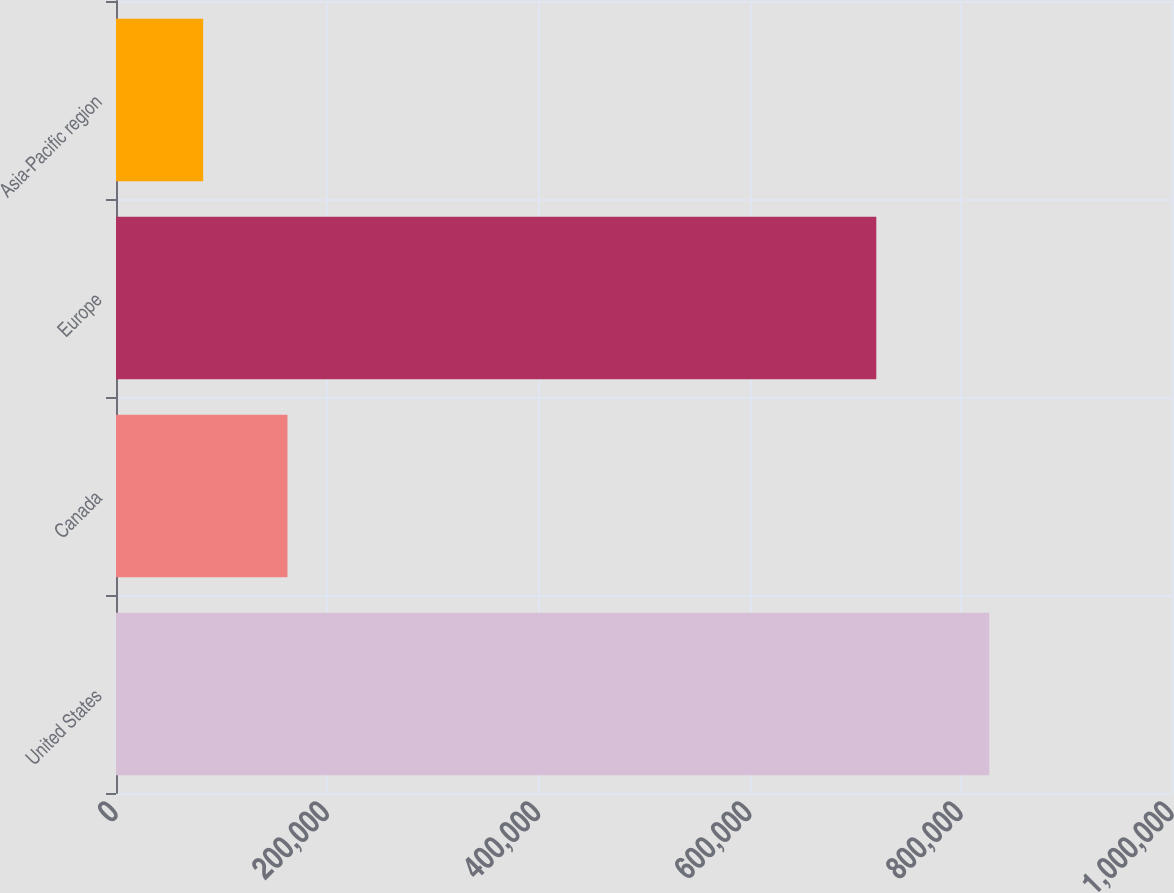<chart> <loc_0><loc_0><loc_500><loc_500><bar_chart><fcel>United States<fcel>Canada<fcel>Europe<fcel>Asia-Pacific region<nl><fcel>826972<fcel>162374<fcel>719991<fcel>82538<nl></chart> 